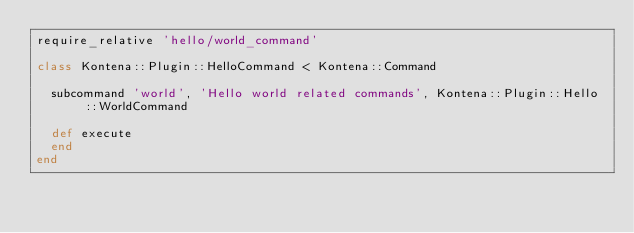Convert code to text. <code><loc_0><loc_0><loc_500><loc_500><_Ruby_>require_relative 'hello/world_command'

class Kontena::Plugin::HelloCommand < Kontena::Command

  subcommand 'world', 'Hello world related commands', Kontena::Plugin::Hello::WorldCommand

  def execute
  end
end
</code> 